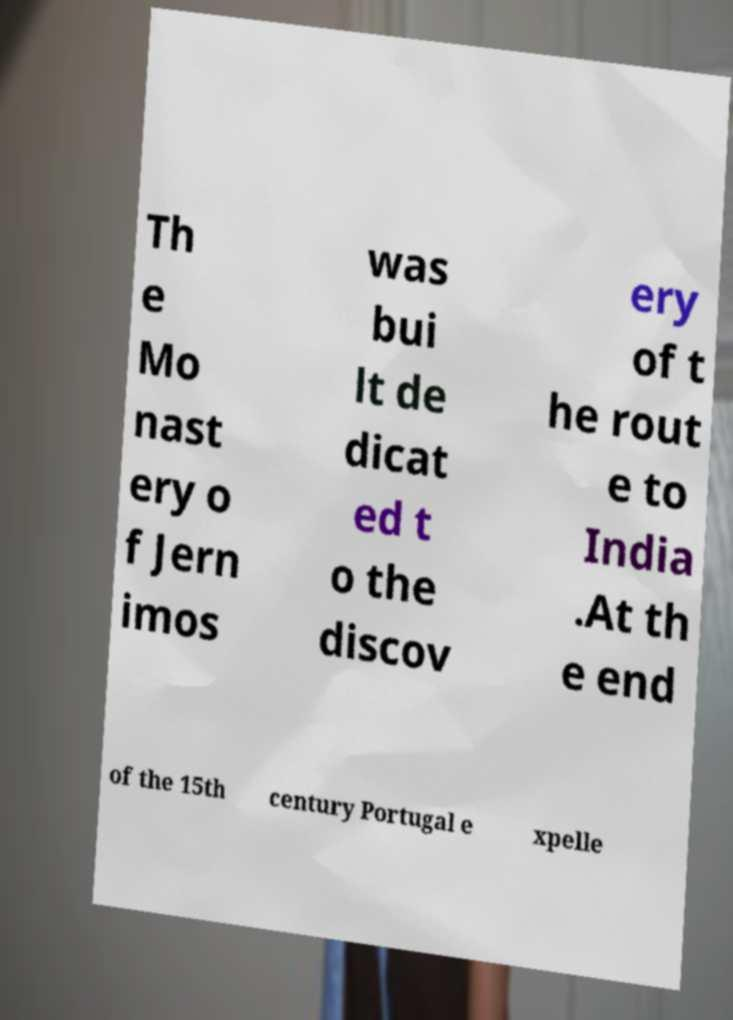For documentation purposes, I need the text within this image transcribed. Could you provide that? Th e Mo nast ery o f Jern imos was bui lt de dicat ed t o the discov ery of t he rout e to India .At th e end of the 15th century Portugal e xpelle 